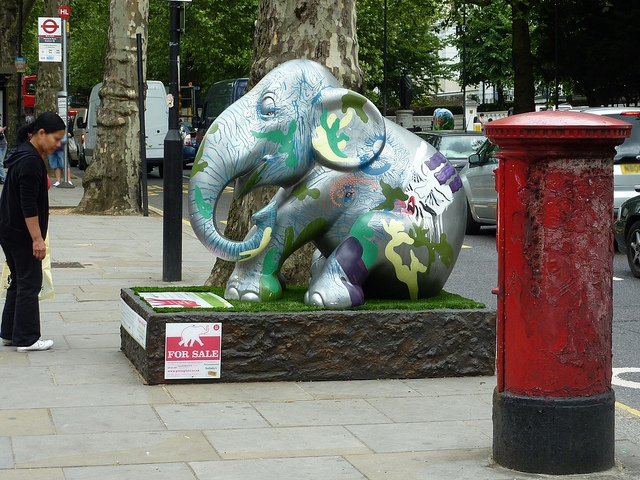<image>What color is the hydrants? I am not sure what color the hydrants are. But it can be seen red. What color is the hydrants? The hydrants in the image are red. 